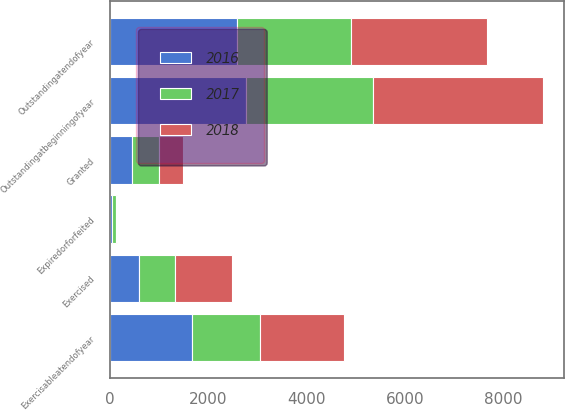Convert chart. <chart><loc_0><loc_0><loc_500><loc_500><stacked_bar_chart><ecel><fcel>Outstandingatbeginningofyear<fcel>Granted<fcel>Exercised<fcel>Expiredorforfeited<fcel>Outstandingatendofyear<fcel>Exercisableatendofyear<nl><fcel>2017<fcel>2579<fcel>538<fcel>736<fcel>71<fcel>2310<fcel>1391<nl><fcel>2016<fcel>2768<fcel>458<fcel>597<fcel>50<fcel>2579<fcel>1661<nl><fcel>2018<fcel>3445<fcel>492<fcel>1143<fcel>26<fcel>2768<fcel>1708<nl></chart> 